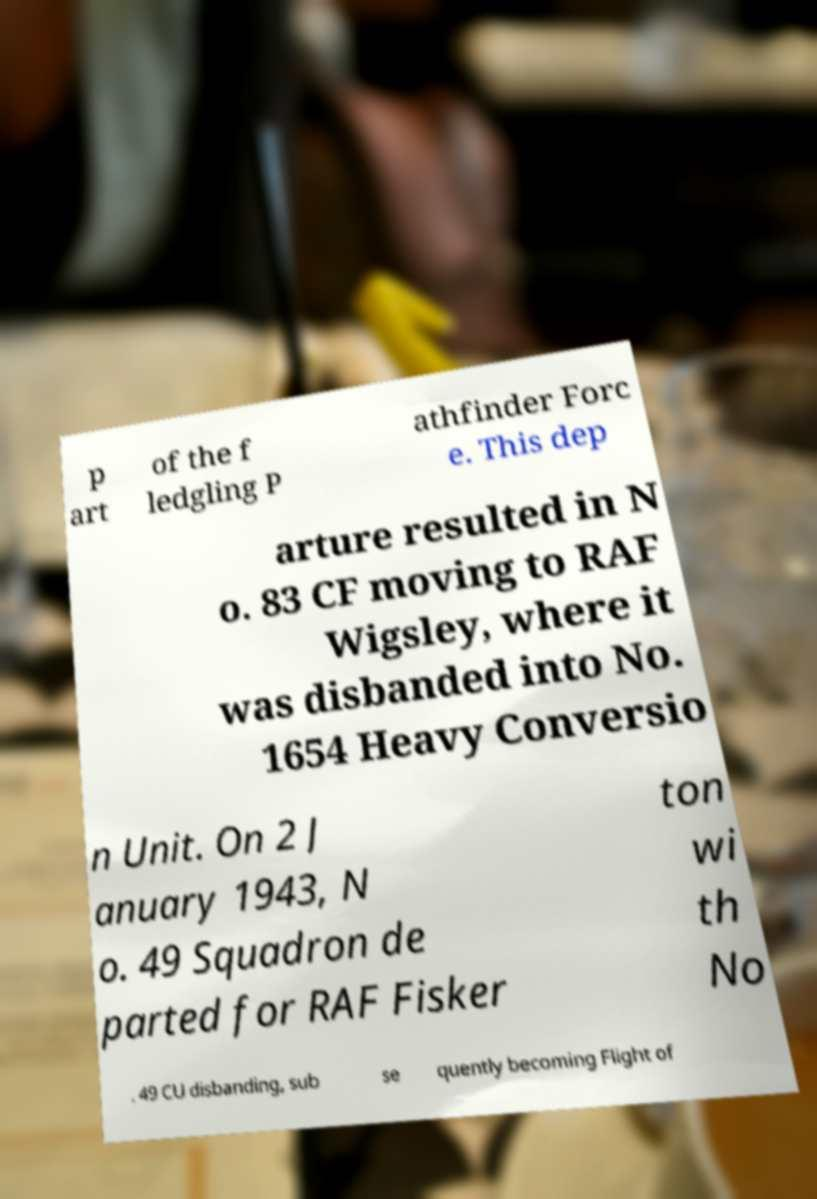Could you extract and type out the text from this image? p art of the f ledgling P athfinder Forc e. This dep arture resulted in N o. 83 CF moving to RAF Wigsley, where it was disbanded into No. 1654 Heavy Conversio n Unit. On 2 J anuary 1943, N o. 49 Squadron de parted for RAF Fisker ton wi th No . 49 CU disbanding, sub se quently becoming Flight of 